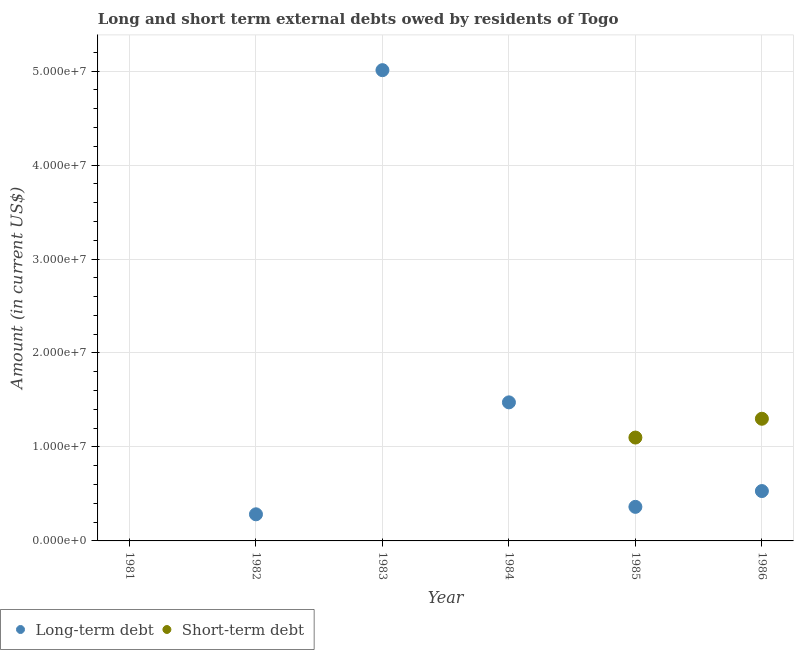What is the long-term debts owed by residents in 1984?
Your answer should be very brief. 1.47e+07. Across all years, what is the maximum short-term debts owed by residents?
Keep it short and to the point. 1.30e+07. Across all years, what is the minimum long-term debts owed by residents?
Ensure brevity in your answer.  0. In which year was the short-term debts owed by residents maximum?
Give a very brief answer. 1986. What is the total short-term debts owed by residents in the graph?
Provide a succinct answer. 2.40e+07. What is the difference between the long-term debts owed by residents in 1983 and that in 1985?
Your response must be concise. 4.65e+07. What is the difference between the short-term debts owed by residents in 1985 and the long-term debts owed by residents in 1983?
Keep it short and to the point. -3.91e+07. What is the average short-term debts owed by residents per year?
Make the answer very short. 4.00e+06. In the year 1986, what is the difference between the long-term debts owed by residents and short-term debts owed by residents?
Ensure brevity in your answer.  -7.69e+06. In how many years, is the short-term debts owed by residents greater than 38000000 US$?
Provide a succinct answer. 0. What is the ratio of the long-term debts owed by residents in 1982 to that in 1983?
Make the answer very short. 0.06. What is the difference between the highest and the second highest long-term debts owed by residents?
Ensure brevity in your answer.  3.54e+07. What is the difference between the highest and the lowest short-term debts owed by residents?
Your answer should be compact. 1.30e+07. In how many years, is the long-term debts owed by residents greater than the average long-term debts owed by residents taken over all years?
Make the answer very short. 2. Is the sum of the long-term debts owed by residents in 1985 and 1986 greater than the maximum short-term debts owed by residents across all years?
Ensure brevity in your answer.  No. Does the long-term debts owed by residents monotonically increase over the years?
Your answer should be compact. No. Is the long-term debts owed by residents strictly less than the short-term debts owed by residents over the years?
Keep it short and to the point. No. What is the difference between two consecutive major ticks on the Y-axis?
Offer a very short reply. 1.00e+07. Does the graph contain any zero values?
Your response must be concise. Yes. Where does the legend appear in the graph?
Keep it short and to the point. Bottom left. What is the title of the graph?
Ensure brevity in your answer.  Long and short term external debts owed by residents of Togo. What is the label or title of the Y-axis?
Provide a succinct answer. Amount (in current US$). What is the Amount (in current US$) of Long-term debt in 1982?
Keep it short and to the point. 2.83e+06. What is the Amount (in current US$) in Short-term debt in 1982?
Your response must be concise. 0. What is the Amount (in current US$) in Long-term debt in 1983?
Give a very brief answer. 5.01e+07. What is the Amount (in current US$) of Long-term debt in 1984?
Your response must be concise. 1.47e+07. What is the Amount (in current US$) in Short-term debt in 1984?
Provide a short and direct response. 0. What is the Amount (in current US$) in Long-term debt in 1985?
Offer a terse response. 3.62e+06. What is the Amount (in current US$) of Short-term debt in 1985?
Your answer should be very brief. 1.10e+07. What is the Amount (in current US$) of Long-term debt in 1986?
Keep it short and to the point. 5.31e+06. What is the Amount (in current US$) of Short-term debt in 1986?
Offer a very short reply. 1.30e+07. Across all years, what is the maximum Amount (in current US$) of Long-term debt?
Your answer should be very brief. 5.01e+07. Across all years, what is the maximum Amount (in current US$) in Short-term debt?
Ensure brevity in your answer.  1.30e+07. Across all years, what is the minimum Amount (in current US$) of Short-term debt?
Make the answer very short. 0. What is the total Amount (in current US$) of Long-term debt in the graph?
Offer a very short reply. 7.66e+07. What is the total Amount (in current US$) in Short-term debt in the graph?
Ensure brevity in your answer.  2.40e+07. What is the difference between the Amount (in current US$) of Long-term debt in 1982 and that in 1983?
Keep it short and to the point. -4.73e+07. What is the difference between the Amount (in current US$) in Long-term debt in 1982 and that in 1984?
Provide a succinct answer. -1.19e+07. What is the difference between the Amount (in current US$) in Long-term debt in 1982 and that in 1985?
Offer a terse response. -7.93e+05. What is the difference between the Amount (in current US$) of Long-term debt in 1982 and that in 1986?
Keep it short and to the point. -2.47e+06. What is the difference between the Amount (in current US$) of Long-term debt in 1983 and that in 1984?
Offer a terse response. 3.54e+07. What is the difference between the Amount (in current US$) in Long-term debt in 1983 and that in 1985?
Offer a terse response. 4.65e+07. What is the difference between the Amount (in current US$) in Long-term debt in 1983 and that in 1986?
Give a very brief answer. 4.48e+07. What is the difference between the Amount (in current US$) in Long-term debt in 1984 and that in 1985?
Provide a short and direct response. 1.11e+07. What is the difference between the Amount (in current US$) of Long-term debt in 1984 and that in 1986?
Offer a terse response. 9.44e+06. What is the difference between the Amount (in current US$) in Long-term debt in 1985 and that in 1986?
Offer a terse response. -1.68e+06. What is the difference between the Amount (in current US$) of Short-term debt in 1985 and that in 1986?
Keep it short and to the point. -2.00e+06. What is the difference between the Amount (in current US$) in Long-term debt in 1982 and the Amount (in current US$) in Short-term debt in 1985?
Your response must be concise. -8.17e+06. What is the difference between the Amount (in current US$) in Long-term debt in 1982 and the Amount (in current US$) in Short-term debt in 1986?
Provide a short and direct response. -1.02e+07. What is the difference between the Amount (in current US$) in Long-term debt in 1983 and the Amount (in current US$) in Short-term debt in 1985?
Give a very brief answer. 3.91e+07. What is the difference between the Amount (in current US$) in Long-term debt in 1983 and the Amount (in current US$) in Short-term debt in 1986?
Keep it short and to the point. 3.71e+07. What is the difference between the Amount (in current US$) in Long-term debt in 1984 and the Amount (in current US$) in Short-term debt in 1985?
Offer a very short reply. 3.74e+06. What is the difference between the Amount (in current US$) in Long-term debt in 1984 and the Amount (in current US$) in Short-term debt in 1986?
Make the answer very short. 1.74e+06. What is the difference between the Amount (in current US$) of Long-term debt in 1985 and the Amount (in current US$) of Short-term debt in 1986?
Offer a terse response. -9.38e+06. What is the average Amount (in current US$) of Long-term debt per year?
Offer a very short reply. 1.28e+07. In the year 1985, what is the difference between the Amount (in current US$) in Long-term debt and Amount (in current US$) in Short-term debt?
Your answer should be compact. -7.38e+06. In the year 1986, what is the difference between the Amount (in current US$) of Long-term debt and Amount (in current US$) of Short-term debt?
Your response must be concise. -7.69e+06. What is the ratio of the Amount (in current US$) in Long-term debt in 1982 to that in 1983?
Make the answer very short. 0.06. What is the ratio of the Amount (in current US$) in Long-term debt in 1982 to that in 1984?
Make the answer very short. 0.19. What is the ratio of the Amount (in current US$) in Long-term debt in 1982 to that in 1985?
Ensure brevity in your answer.  0.78. What is the ratio of the Amount (in current US$) in Long-term debt in 1982 to that in 1986?
Make the answer very short. 0.53. What is the ratio of the Amount (in current US$) of Long-term debt in 1983 to that in 1984?
Your answer should be compact. 3.4. What is the ratio of the Amount (in current US$) of Long-term debt in 1983 to that in 1985?
Ensure brevity in your answer.  13.82. What is the ratio of the Amount (in current US$) in Long-term debt in 1983 to that in 1986?
Your answer should be very brief. 9.44. What is the ratio of the Amount (in current US$) in Long-term debt in 1984 to that in 1985?
Your response must be concise. 4.07. What is the ratio of the Amount (in current US$) of Long-term debt in 1984 to that in 1986?
Keep it short and to the point. 2.78. What is the ratio of the Amount (in current US$) in Long-term debt in 1985 to that in 1986?
Provide a short and direct response. 0.68. What is the ratio of the Amount (in current US$) of Short-term debt in 1985 to that in 1986?
Offer a terse response. 0.85. What is the difference between the highest and the second highest Amount (in current US$) of Long-term debt?
Make the answer very short. 3.54e+07. What is the difference between the highest and the lowest Amount (in current US$) of Long-term debt?
Provide a short and direct response. 5.01e+07. What is the difference between the highest and the lowest Amount (in current US$) of Short-term debt?
Offer a very short reply. 1.30e+07. 